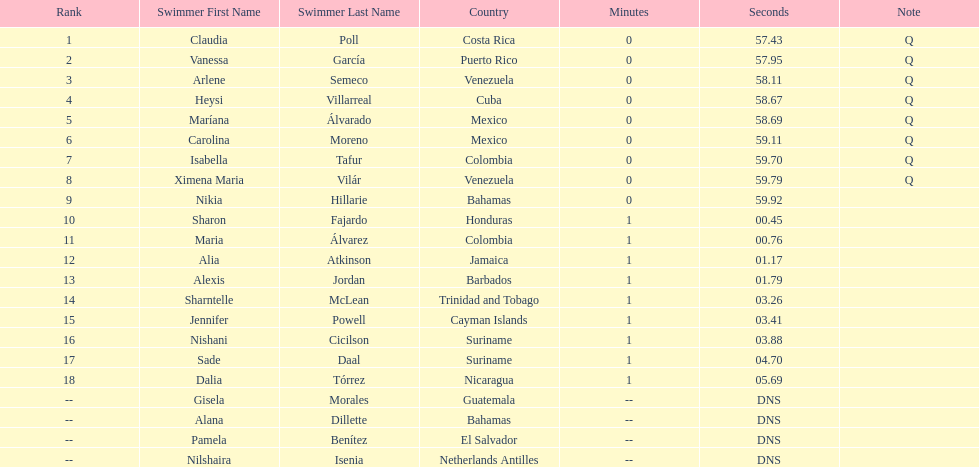Who finished after claudia poll? Vanessa García. 